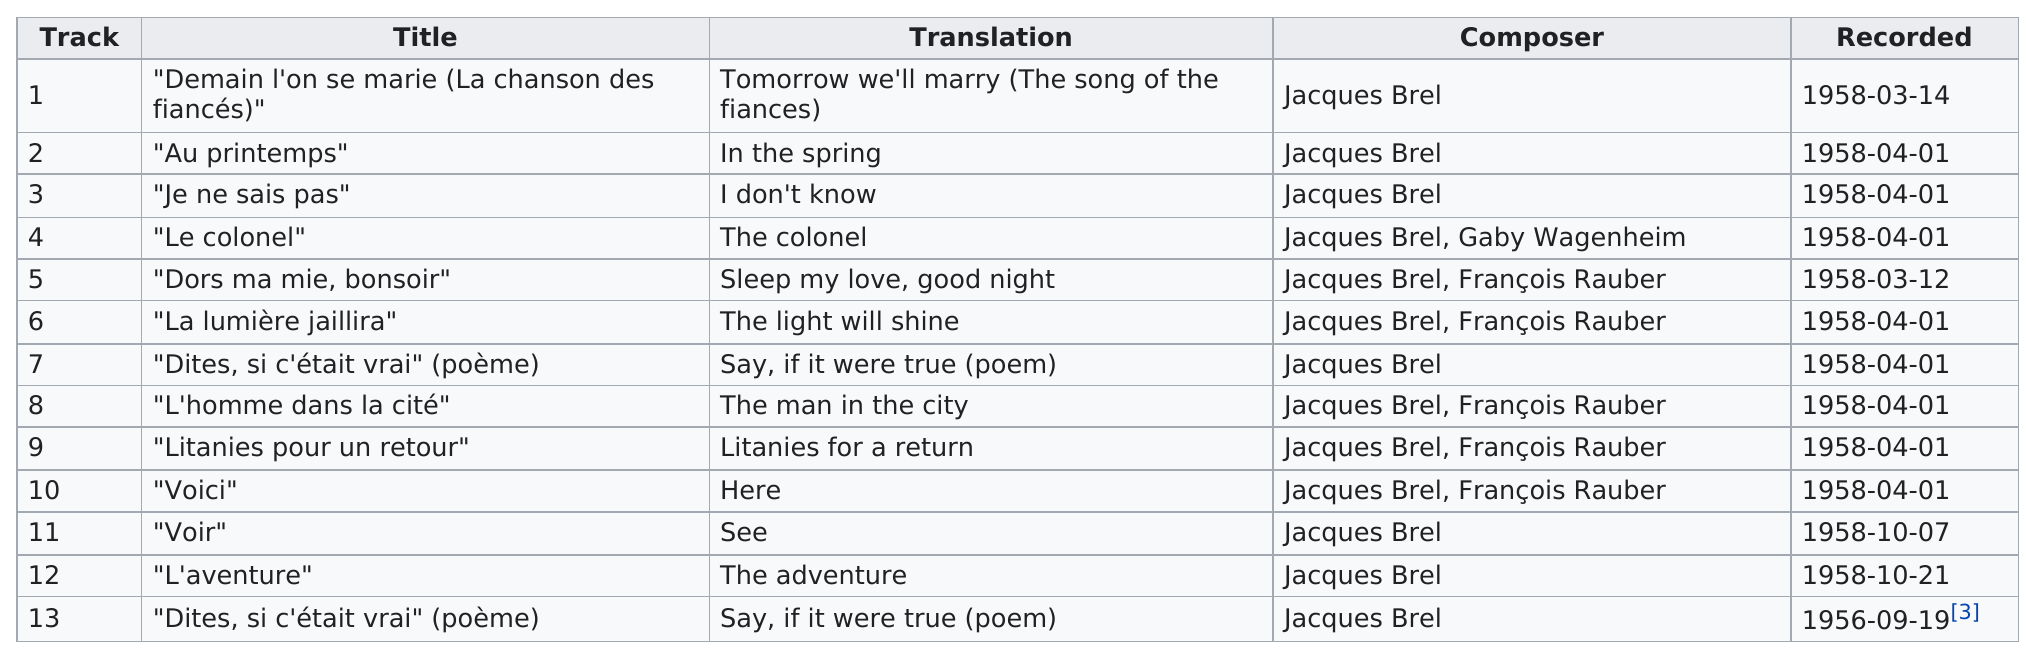List a handful of essential elements in this visual. This album contains 13 tracks. The majority of the songs on this album were recorded in April. Jacques Brel is the composer with the most credits on the album. Jacques Brel and Gaby Wagenheim composed the track titled 'Le colonel.' The recording of track three took place on April 1, 1958. 